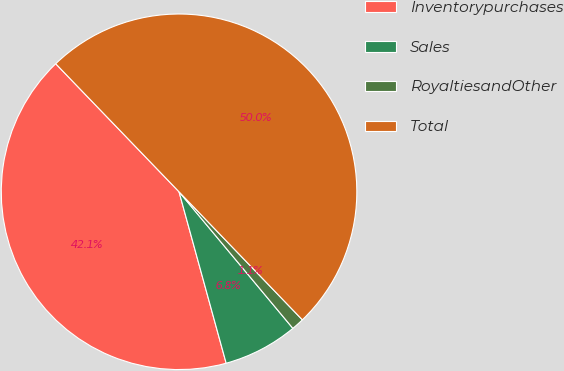<chart> <loc_0><loc_0><loc_500><loc_500><pie_chart><fcel>Inventorypurchases<fcel>Sales<fcel>RoyaltiesandOther<fcel>Total<nl><fcel>42.07%<fcel>6.79%<fcel>1.14%<fcel>50.0%<nl></chart> 